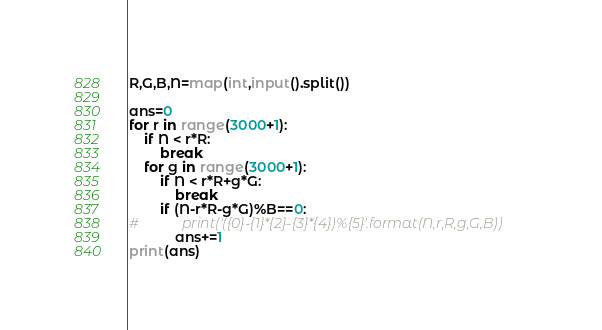<code> <loc_0><loc_0><loc_500><loc_500><_Python_>R,G,B,N=map(int,input().split())

ans=0
for r in range(3000+1):
    if N < r*R:
        break
    for g in range(3000+1):
        if N < r*R+g*G:
            break
        if (N-r*R-g*G)%B==0:
#            print('({0}-{1}*{2}-{3}*{4})%{5}'.format(N,r,R,g,G,B))
            ans+=1
print(ans)</code> 